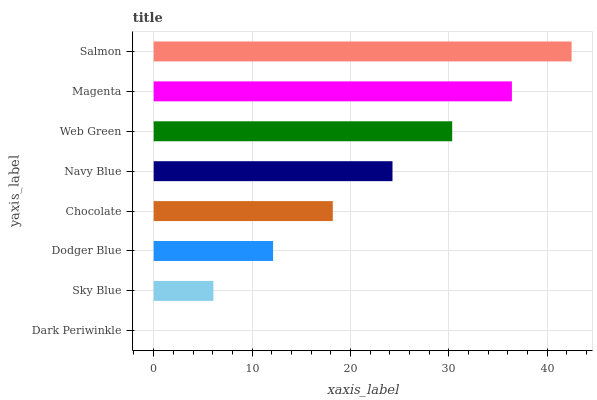Is Dark Periwinkle the minimum?
Answer yes or no. Yes. Is Salmon the maximum?
Answer yes or no. Yes. Is Sky Blue the minimum?
Answer yes or no. No. Is Sky Blue the maximum?
Answer yes or no. No. Is Sky Blue greater than Dark Periwinkle?
Answer yes or no. Yes. Is Dark Periwinkle less than Sky Blue?
Answer yes or no. Yes. Is Dark Periwinkle greater than Sky Blue?
Answer yes or no. No. Is Sky Blue less than Dark Periwinkle?
Answer yes or no. No. Is Navy Blue the high median?
Answer yes or no. Yes. Is Chocolate the low median?
Answer yes or no. Yes. Is Chocolate the high median?
Answer yes or no. No. Is Dark Periwinkle the low median?
Answer yes or no. No. 